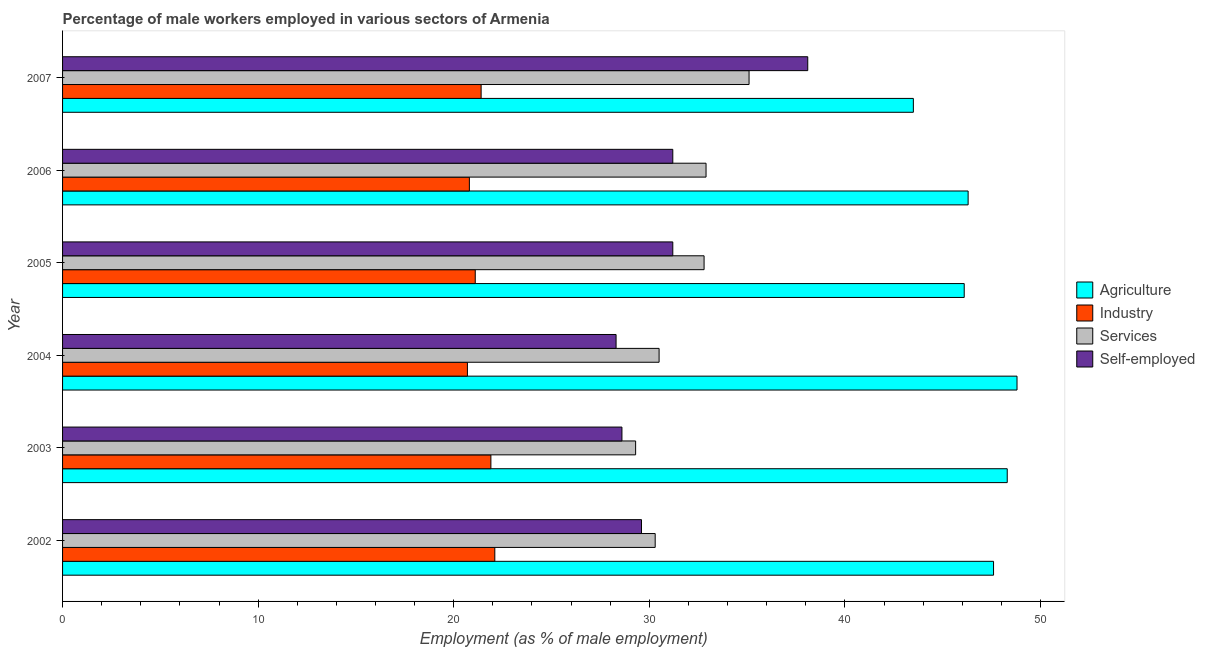How many different coloured bars are there?
Keep it short and to the point. 4. Are the number of bars on each tick of the Y-axis equal?
Your answer should be compact. Yes. How many bars are there on the 1st tick from the bottom?
Give a very brief answer. 4. What is the label of the 1st group of bars from the top?
Offer a very short reply. 2007. In how many cases, is the number of bars for a given year not equal to the number of legend labels?
Your answer should be very brief. 0. What is the percentage of male workers in industry in 2002?
Your answer should be compact. 22.1. Across all years, what is the maximum percentage of male workers in agriculture?
Offer a very short reply. 48.8. Across all years, what is the minimum percentage of male workers in agriculture?
Your response must be concise. 43.5. In which year was the percentage of male workers in industry minimum?
Keep it short and to the point. 2004. What is the total percentage of male workers in agriculture in the graph?
Your response must be concise. 280.6. What is the difference between the percentage of self employed male workers in 2006 and that in 2007?
Ensure brevity in your answer.  -6.9. What is the difference between the percentage of male workers in agriculture in 2005 and the percentage of male workers in services in 2007?
Your answer should be compact. 11. What is the average percentage of self employed male workers per year?
Make the answer very short. 31.17. What is the ratio of the percentage of male workers in services in 2005 to that in 2007?
Provide a succinct answer. 0.93. Is the percentage of male workers in agriculture in 2004 less than that in 2005?
Offer a very short reply. No. Is the difference between the percentage of male workers in industry in 2002 and 2006 greater than the difference between the percentage of male workers in services in 2002 and 2006?
Ensure brevity in your answer.  Yes. What is the difference between the highest and the lowest percentage of male workers in industry?
Make the answer very short. 1.4. Is the sum of the percentage of self employed male workers in 2002 and 2003 greater than the maximum percentage of male workers in industry across all years?
Ensure brevity in your answer.  Yes. What does the 4th bar from the top in 2005 represents?
Your answer should be compact. Agriculture. What does the 1st bar from the bottom in 2003 represents?
Your answer should be very brief. Agriculture. Is it the case that in every year, the sum of the percentage of male workers in agriculture and percentage of male workers in industry is greater than the percentage of male workers in services?
Make the answer very short. Yes. Are all the bars in the graph horizontal?
Offer a very short reply. Yes. Does the graph contain any zero values?
Keep it short and to the point. No. How many legend labels are there?
Offer a terse response. 4. What is the title of the graph?
Provide a succinct answer. Percentage of male workers employed in various sectors of Armenia. What is the label or title of the X-axis?
Provide a succinct answer. Employment (as % of male employment). What is the label or title of the Y-axis?
Your answer should be very brief. Year. What is the Employment (as % of male employment) in Agriculture in 2002?
Make the answer very short. 47.6. What is the Employment (as % of male employment) in Industry in 2002?
Your response must be concise. 22.1. What is the Employment (as % of male employment) in Services in 2002?
Ensure brevity in your answer.  30.3. What is the Employment (as % of male employment) in Self-employed in 2002?
Your answer should be compact. 29.6. What is the Employment (as % of male employment) of Agriculture in 2003?
Give a very brief answer. 48.3. What is the Employment (as % of male employment) in Industry in 2003?
Give a very brief answer. 21.9. What is the Employment (as % of male employment) in Services in 2003?
Provide a short and direct response. 29.3. What is the Employment (as % of male employment) in Self-employed in 2003?
Your answer should be compact. 28.6. What is the Employment (as % of male employment) of Agriculture in 2004?
Offer a terse response. 48.8. What is the Employment (as % of male employment) of Industry in 2004?
Offer a very short reply. 20.7. What is the Employment (as % of male employment) of Services in 2004?
Give a very brief answer. 30.5. What is the Employment (as % of male employment) of Self-employed in 2004?
Provide a short and direct response. 28.3. What is the Employment (as % of male employment) in Agriculture in 2005?
Provide a succinct answer. 46.1. What is the Employment (as % of male employment) of Industry in 2005?
Provide a short and direct response. 21.1. What is the Employment (as % of male employment) in Services in 2005?
Give a very brief answer. 32.8. What is the Employment (as % of male employment) in Self-employed in 2005?
Ensure brevity in your answer.  31.2. What is the Employment (as % of male employment) in Agriculture in 2006?
Offer a terse response. 46.3. What is the Employment (as % of male employment) of Industry in 2006?
Your response must be concise. 20.8. What is the Employment (as % of male employment) of Services in 2006?
Your answer should be very brief. 32.9. What is the Employment (as % of male employment) in Self-employed in 2006?
Your answer should be very brief. 31.2. What is the Employment (as % of male employment) in Agriculture in 2007?
Make the answer very short. 43.5. What is the Employment (as % of male employment) in Industry in 2007?
Ensure brevity in your answer.  21.4. What is the Employment (as % of male employment) in Services in 2007?
Offer a very short reply. 35.1. What is the Employment (as % of male employment) of Self-employed in 2007?
Provide a succinct answer. 38.1. Across all years, what is the maximum Employment (as % of male employment) of Agriculture?
Make the answer very short. 48.8. Across all years, what is the maximum Employment (as % of male employment) of Industry?
Your response must be concise. 22.1. Across all years, what is the maximum Employment (as % of male employment) of Services?
Make the answer very short. 35.1. Across all years, what is the maximum Employment (as % of male employment) of Self-employed?
Offer a very short reply. 38.1. Across all years, what is the minimum Employment (as % of male employment) in Agriculture?
Keep it short and to the point. 43.5. Across all years, what is the minimum Employment (as % of male employment) in Industry?
Provide a short and direct response. 20.7. Across all years, what is the minimum Employment (as % of male employment) of Services?
Your answer should be very brief. 29.3. Across all years, what is the minimum Employment (as % of male employment) in Self-employed?
Your answer should be compact. 28.3. What is the total Employment (as % of male employment) of Agriculture in the graph?
Your answer should be compact. 280.6. What is the total Employment (as % of male employment) of Industry in the graph?
Keep it short and to the point. 128. What is the total Employment (as % of male employment) of Services in the graph?
Offer a terse response. 190.9. What is the total Employment (as % of male employment) in Self-employed in the graph?
Your answer should be very brief. 187. What is the difference between the Employment (as % of male employment) of Industry in 2002 and that in 2003?
Give a very brief answer. 0.2. What is the difference between the Employment (as % of male employment) of Industry in 2002 and that in 2004?
Your answer should be compact. 1.4. What is the difference between the Employment (as % of male employment) of Services in 2002 and that in 2004?
Your answer should be very brief. -0.2. What is the difference between the Employment (as % of male employment) of Self-employed in 2002 and that in 2004?
Provide a short and direct response. 1.3. What is the difference between the Employment (as % of male employment) in Agriculture in 2002 and that in 2005?
Ensure brevity in your answer.  1.5. What is the difference between the Employment (as % of male employment) of Industry in 2002 and that in 2005?
Ensure brevity in your answer.  1. What is the difference between the Employment (as % of male employment) in Services in 2002 and that in 2005?
Ensure brevity in your answer.  -2.5. What is the difference between the Employment (as % of male employment) in Services in 2002 and that in 2006?
Offer a terse response. -2.6. What is the difference between the Employment (as % of male employment) of Self-employed in 2002 and that in 2006?
Make the answer very short. -1.6. What is the difference between the Employment (as % of male employment) in Agriculture in 2002 and that in 2007?
Provide a succinct answer. 4.1. What is the difference between the Employment (as % of male employment) in Industry in 2002 and that in 2007?
Your answer should be compact. 0.7. What is the difference between the Employment (as % of male employment) of Agriculture in 2003 and that in 2004?
Offer a very short reply. -0.5. What is the difference between the Employment (as % of male employment) of Industry in 2003 and that in 2004?
Provide a short and direct response. 1.2. What is the difference between the Employment (as % of male employment) in Agriculture in 2003 and that in 2005?
Your answer should be very brief. 2.2. What is the difference between the Employment (as % of male employment) in Services in 2003 and that in 2005?
Your answer should be very brief. -3.5. What is the difference between the Employment (as % of male employment) of Self-employed in 2003 and that in 2005?
Ensure brevity in your answer.  -2.6. What is the difference between the Employment (as % of male employment) of Agriculture in 2003 and that in 2006?
Provide a succinct answer. 2. What is the difference between the Employment (as % of male employment) in Services in 2003 and that in 2006?
Your answer should be very brief. -3.6. What is the difference between the Employment (as % of male employment) in Agriculture in 2003 and that in 2007?
Your answer should be compact. 4.8. What is the difference between the Employment (as % of male employment) in Industry in 2003 and that in 2007?
Your answer should be very brief. 0.5. What is the difference between the Employment (as % of male employment) in Services in 2003 and that in 2007?
Make the answer very short. -5.8. What is the difference between the Employment (as % of male employment) of Self-employed in 2003 and that in 2007?
Make the answer very short. -9.5. What is the difference between the Employment (as % of male employment) of Agriculture in 2004 and that in 2006?
Keep it short and to the point. 2.5. What is the difference between the Employment (as % of male employment) in Industry in 2004 and that in 2006?
Your response must be concise. -0.1. What is the difference between the Employment (as % of male employment) of Services in 2004 and that in 2006?
Offer a very short reply. -2.4. What is the difference between the Employment (as % of male employment) of Agriculture in 2004 and that in 2007?
Make the answer very short. 5.3. What is the difference between the Employment (as % of male employment) of Self-employed in 2004 and that in 2007?
Offer a terse response. -9.8. What is the difference between the Employment (as % of male employment) in Self-employed in 2005 and that in 2006?
Your answer should be compact. 0. What is the difference between the Employment (as % of male employment) of Industry in 2005 and that in 2007?
Make the answer very short. -0.3. What is the difference between the Employment (as % of male employment) of Agriculture in 2006 and that in 2007?
Provide a succinct answer. 2.8. What is the difference between the Employment (as % of male employment) of Industry in 2006 and that in 2007?
Give a very brief answer. -0.6. What is the difference between the Employment (as % of male employment) of Services in 2006 and that in 2007?
Give a very brief answer. -2.2. What is the difference between the Employment (as % of male employment) in Agriculture in 2002 and the Employment (as % of male employment) in Industry in 2003?
Keep it short and to the point. 25.7. What is the difference between the Employment (as % of male employment) of Services in 2002 and the Employment (as % of male employment) of Self-employed in 2003?
Offer a terse response. 1.7. What is the difference between the Employment (as % of male employment) of Agriculture in 2002 and the Employment (as % of male employment) of Industry in 2004?
Offer a very short reply. 26.9. What is the difference between the Employment (as % of male employment) of Agriculture in 2002 and the Employment (as % of male employment) of Self-employed in 2004?
Give a very brief answer. 19.3. What is the difference between the Employment (as % of male employment) of Industry in 2002 and the Employment (as % of male employment) of Self-employed in 2004?
Ensure brevity in your answer.  -6.2. What is the difference between the Employment (as % of male employment) of Industry in 2002 and the Employment (as % of male employment) of Services in 2005?
Keep it short and to the point. -10.7. What is the difference between the Employment (as % of male employment) in Services in 2002 and the Employment (as % of male employment) in Self-employed in 2005?
Provide a short and direct response. -0.9. What is the difference between the Employment (as % of male employment) of Agriculture in 2002 and the Employment (as % of male employment) of Industry in 2006?
Offer a terse response. 26.8. What is the difference between the Employment (as % of male employment) in Agriculture in 2002 and the Employment (as % of male employment) in Self-employed in 2006?
Your answer should be very brief. 16.4. What is the difference between the Employment (as % of male employment) of Industry in 2002 and the Employment (as % of male employment) of Services in 2006?
Provide a succinct answer. -10.8. What is the difference between the Employment (as % of male employment) of Industry in 2002 and the Employment (as % of male employment) of Self-employed in 2006?
Keep it short and to the point. -9.1. What is the difference between the Employment (as % of male employment) in Agriculture in 2002 and the Employment (as % of male employment) in Industry in 2007?
Your answer should be compact. 26.2. What is the difference between the Employment (as % of male employment) of Agriculture in 2002 and the Employment (as % of male employment) of Self-employed in 2007?
Ensure brevity in your answer.  9.5. What is the difference between the Employment (as % of male employment) in Industry in 2002 and the Employment (as % of male employment) in Self-employed in 2007?
Give a very brief answer. -16. What is the difference between the Employment (as % of male employment) in Agriculture in 2003 and the Employment (as % of male employment) in Industry in 2004?
Give a very brief answer. 27.6. What is the difference between the Employment (as % of male employment) of Agriculture in 2003 and the Employment (as % of male employment) of Services in 2004?
Your answer should be compact. 17.8. What is the difference between the Employment (as % of male employment) of Industry in 2003 and the Employment (as % of male employment) of Services in 2004?
Keep it short and to the point. -8.6. What is the difference between the Employment (as % of male employment) of Services in 2003 and the Employment (as % of male employment) of Self-employed in 2004?
Your response must be concise. 1. What is the difference between the Employment (as % of male employment) of Agriculture in 2003 and the Employment (as % of male employment) of Industry in 2005?
Your response must be concise. 27.2. What is the difference between the Employment (as % of male employment) in Agriculture in 2003 and the Employment (as % of male employment) in Self-employed in 2005?
Your answer should be very brief. 17.1. What is the difference between the Employment (as % of male employment) in Industry in 2003 and the Employment (as % of male employment) in Services in 2005?
Ensure brevity in your answer.  -10.9. What is the difference between the Employment (as % of male employment) in Agriculture in 2003 and the Employment (as % of male employment) in Services in 2006?
Ensure brevity in your answer.  15.4. What is the difference between the Employment (as % of male employment) in Industry in 2003 and the Employment (as % of male employment) in Self-employed in 2006?
Make the answer very short. -9.3. What is the difference between the Employment (as % of male employment) of Services in 2003 and the Employment (as % of male employment) of Self-employed in 2006?
Offer a very short reply. -1.9. What is the difference between the Employment (as % of male employment) of Agriculture in 2003 and the Employment (as % of male employment) of Industry in 2007?
Your response must be concise. 26.9. What is the difference between the Employment (as % of male employment) of Agriculture in 2003 and the Employment (as % of male employment) of Services in 2007?
Provide a short and direct response. 13.2. What is the difference between the Employment (as % of male employment) in Agriculture in 2003 and the Employment (as % of male employment) in Self-employed in 2007?
Provide a short and direct response. 10.2. What is the difference between the Employment (as % of male employment) of Industry in 2003 and the Employment (as % of male employment) of Self-employed in 2007?
Make the answer very short. -16.2. What is the difference between the Employment (as % of male employment) in Services in 2003 and the Employment (as % of male employment) in Self-employed in 2007?
Your response must be concise. -8.8. What is the difference between the Employment (as % of male employment) of Agriculture in 2004 and the Employment (as % of male employment) of Industry in 2005?
Ensure brevity in your answer.  27.7. What is the difference between the Employment (as % of male employment) of Agriculture in 2004 and the Employment (as % of male employment) of Services in 2005?
Offer a terse response. 16. What is the difference between the Employment (as % of male employment) in Agriculture in 2004 and the Employment (as % of male employment) in Self-employed in 2005?
Your answer should be compact. 17.6. What is the difference between the Employment (as % of male employment) in Industry in 2004 and the Employment (as % of male employment) in Services in 2005?
Keep it short and to the point. -12.1. What is the difference between the Employment (as % of male employment) of Industry in 2004 and the Employment (as % of male employment) of Self-employed in 2006?
Your answer should be very brief. -10.5. What is the difference between the Employment (as % of male employment) in Agriculture in 2004 and the Employment (as % of male employment) in Industry in 2007?
Keep it short and to the point. 27.4. What is the difference between the Employment (as % of male employment) of Industry in 2004 and the Employment (as % of male employment) of Services in 2007?
Keep it short and to the point. -14.4. What is the difference between the Employment (as % of male employment) of Industry in 2004 and the Employment (as % of male employment) of Self-employed in 2007?
Provide a short and direct response. -17.4. What is the difference between the Employment (as % of male employment) of Agriculture in 2005 and the Employment (as % of male employment) of Industry in 2006?
Offer a very short reply. 25.3. What is the difference between the Employment (as % of male employment) of Agriculture in 2005 and the Employment (as % of male employment) of Self-employed in 2006?
Provide a succinct answer. 14.9. What is the difference between the Employment (as % of male employment) of Industry in 2005 and the Employment (as % of male employment) of Services in 2006?
Your response must be concise. -11.8. What is the difference between the Employment (as % of male employment) in Industry in 2005 and the Employment (as % of male employment) in Self-employed in 2006?
Provide a short and direct response. -10.1. What is the difference between the Employment (as % of male employment) of Agriculture in 2005 and the Employment (as % of male employment) of Industry in 2007?
Offer a terse response. 24.7. What is the difference between the Employment (as % of male employment) of Agriculture in 2005 and the Employment (as % of male employment) of Self-employed in 2007?
Give a very brief answer. 8. What is the difference between the Employment (as % of male employment) of Services in 2005 and the Employment (as % of male employment) of Self-employed in 2007?
Your response must be concise. -5.3. What is the difference between the Employment (as % of male employment) of Agriculture in 2006 and the Employment (as % of male employment) of Industry in 2007?
Ensure brevity in your answer.  24.9. What is the difference between the Employment (as % of male employment) in Agriculture in 2006 and the Employment (as % of male employment) in Self-employed in 2007?
Make the answer very short. 8.2. What is the difference between the Employment (as % of male employment) of Industry in 2006 and the Employment (as % of male employment) of Services in 2007?
Make the answer very short. -14.3. What is the difference between the Employment (as % of male employment) of Industry in 2006 and the Employment (as % of male employment) of Self-employed in 2007?
Your response must be concise. -17.3. What is the average Employment (as % of male employment) of Agriculture per year?
Your answer should be compact. 46.77. What is the average Employment (as % of male employment) of Industry per year?
Offer a very short reply. 21.33. What is the average Employment (as % of male employment) of Services per year?
Ensure brevity in your answer.  31.82. What is the average Employment (as % of male employment) in Self-employed per year?
Your response must be concise. 31.17. In the year 2002, what is the difference between the Employment (as % of male employment) in Agriculture and Employment (as % of male employment) in Industry?
Provide a short and direct response. 25.5. In the year 2002, what is the difference between the Employment (as % of male employment) in Industry and Employment (as % of male employment) in Services?
Provide a short and direct response. -8.2. In the year 2002, what is the difference between the Employment (as % of male employment) in Industry and Employment (as % of male employment) in Self-employed?
Offer a very short reply. -7.5. In the year 2003, what is the difference between the Employment (as % of male employment) of Agriculture and Employment (as % of male employment) of Industry?
Provide a short and direct response. 26.4. In the year 2003, what is the difference between the Employment (as % of male employment) of Industry and Employment (as % of male employment) of Services?
Give a very brief answer. -7.4. In the year 2003, what is the difference between the Employment (as % of male employment) of Industry and Employment (as % of male employment) of Self-employed?
Ensure brevity in your answer.  -6.7. In the year 2003, what is the difference between the Employment (as % of male employment) of Services and Employment (as % of male employment) of Self-employed?
Provide a short and direct response. 0.7. In the year 2004, what is the difference between the Employment (as % of male employment) of Agriculture and Employment (as % of male employment) of Industry?
Provide a short and direct response. 28.1. In the year 2004, what is the difference between the Employment (as % of male employment) in Industry and Employment (as % of male employment) in Services?
Your response must be concise. -9.8. In the year 2004, what is the difference between the Employment (as % of male employment) in Industry and Employment (as % of male employment) in Self-employed?
Give a very brief answer. -7.6. In the year 2005, what is the difference between the Employment (as % of male employment) of Agriculture and Employment (as % of male employment) of Services?
Provide a short and direct response. 13.3. In the year 2005, what is the difference between the Employment (as % of male employment) of Services and Employment (as % of male employment) of Self-employed?
Give a very brief answer. 1.6. In the year 2006, what is the difference between the Employment (as % of male employment) of Agriculture and Employment (as % of male employment) of Industry?
Give a very brief answer. 25.5. In the year 2006, what is the difference between the Employment (as % of male employment) in Industry and Employment (as % of male employment) in Services?
Your answer should be compact. -12.1. In the year 2006, what is the difference between the Employment (as % of male employment) in Services and Employment (as % of male employment) in Self-employed?
Ensure brevity in your answer.  1.7. In the year 2007, what is the difference between the Employment (as % of male employment) of Agriculture and Employment (as % of male employment) of Industry?
Provide a short and direct response. 22.1. In the year 2007, what is the difference between the Employment (as % of male employment) of Agriculture and Employment (as % of male employment) of Self-employed?
Make the answer very short. 5.4. In the year 2007, what is the difference between the Employment (as % of male employment) of Industry and Employment (as % of male employment) of Services?
Give a very brief answer. -13.7. In the year 2007, what is the difference between the Employment (as % of male employment) in Industry and Employment (as % of male employment) in Self-employed?
Give a very brief answer. -16.7. In the year 2007, what is the difference between the Employment (as % of male employment) of Services and Employment (as % of male employment) of Self-employed?
Your answer should be compact. -3. What is the ratio of the Employment (as % of male employment) in Agriculture in 2002 to that in 2003?
Your answer should be very brief. 0.99. What is the ratio of the Employment (as % of male employment) in Industry in 2002 to that in 2003?
Ensure brevity in your answer.  1.01. What is the ratio of the Employment (as % of male employment) of Services in 2002 to that in 2003?
Your answer should be compact. 1.03. What is the ratio of the Employment (as % of male employment) of Self-employed in 2002 to that in 2003?
Keep it short and to the point. 1.03. What is the ratio of the Employment (as % of male employment) of Agriculture in 2002 to that in 2004?
Keep it short and to the point. 0.98. What is the ratio of the Employment (as % of male employment) in Industry in 2002 to that in 2004?
Your answer should be compact. 1.07. What is the ratio of the Employment (as % of male employment) of Self-employed in 2002 to that in 2004?
Your response must be concise. 1.05. What is the ratio of the Employment (as % of male employment) of Agriculture in 2002 to that in 2005?
Provide a short and direct response. 1.03. What is the ratio of the Employment (as % of male employment) in Industry in 2002 to that in 2005?
Make the answer very short. 1.05. What is the ratio of the Employment (as % of male employment) of Services in 2002 to that in 2005?
Provide a succinct answer. 0.92. What is the ratio of the Employment (as % of male employment) in Self-employed in 2002 to that in 2005?
Your answer should be compact. 0.95. What is the ratio of the Employment (as % of male employment) in Agriculture in 2002 to that in 2006?
Ensure brevity in your answer.  1.03. What is the ratio of the Employment (as % of male employment) of Services in 2002 to that in 2006?
Offer a terse response. 0.92. What is the ratio of the Employment (as % of male employment) in Self-employed in 2002 to that in 2006?
Provide a succinct answer. 0.95. What is the ratio of the Employment (as % of male employment) in Agriculture in 2002 to that in 2007?
Ensure brevity in your answer.  1.09. What is the ratio of the Employment (as % of male employment) in Industry in 2002 to that in 2007?
Your answer should be compact. 1.03. What is the ratio of the Employment (as % of male employment) of Services in 2002 to that in 2007?
Provide a succinct answer. 0.86. What is the ratio of the Employment (as % of male employment) of Self-employed in 2002 to that in 2007?
Offer a terse response. 0.78. What is the ratio of the Employment (as % of male employment) in Agriculture in 2003 to that in 2004?
Provide a succinct answer. 0.99. What is the ratio of the Employment (as % of male employment) in Industry in 2003 to that in 2004?
Keep it short and to the point. 1.06. What is the ratio of the Employment (as % of male employment) in Services in 2003 to that in 2004?
Your response must be concise. 0.96. What is the ratio of the Employment (as % of male employment) in Self-employed in 2003 to that in 2004?
Provide a short and direct response. 1.01. What is the ratio of the Employment (as % of male employment) of Agriculture in 2003 to that in 2005?
Your response must be concise. 1.05. What is the ratio of the Employment (as % of male employment) in Industry in 2003 to that in 2005?
Provide a short and direct response. 1.04. What is the ratio of the Employment (as % of male employment) in Services in 2003 to that in 2005?
Make the answer very short. 0.89. What is the ratio of the Employment (as % of male employment) in Self-employed in 2003 to that in 2005?
Your response must be concise. 0.92. What is the ratio of the Employment (as % of male employment) in Agriculture in 2003 to that in 2006?
Your answer should be compact. 1.04. What is the ratio of the Employment (as % of male employment) of Industry in 2003 to that in 2006?
Your answer should be compact. 1.05. What is the ratio of the Employment (as % of male employment) in Services in 2003 to that in 2006?
Make the answer very short. 0.89. What is the ratio of the Employment (as % of male employment) of Self-employed in 2003 to that in 2006?
Your answer should be very brief. 0.92. What is the ratio of the Employment (as % of male employment) in Agriculture in 2003 to that in 2007?
Ensure brevity in your answer.  1.11. What is the ratio of the Employment (as % of male employment) in Industry in 2003 to that in 2007?
Keep it short and to the point. 1.02. What is the ratio of the Employment (as % of male employment) in Services in 2003 to that in 2007?
Ensure brevity in your answer.  0.83. What is the ratio of the Employment (as % of male employment) of Self-employed in 2003 to that in 2007?
Ensure brevity in your answer.  0.75. What is the ratio of the Employment (as % of male employment) of Agriculture in 2004 to that in 2005?
Give a very brief answer. 1.06. What is the ratio of the Employment (as % of male employment) in Services in 2004 to that in 2005?
Your answer should be very brief. 0.93. What is the ratio of the Employment (as % of male employment) in Self-employed in 2004 to that in 2005?
Your answer should be compact. 0.91. What is the ratio of the Employment (as % of male employment) of Agriculture in 2004 to that in 2006?
Your answer should be compact. 1.05. What is the ratio of the Employment (as % of male employment) in Industry in 2004 to that in 2006?
Provide a short and direct response. 1. What is the ratio of the Employment (as % of male employment) of Services in 2004 to that in 2006?
Give a very brief answer. 0.93. What is the ratio of the Employment (as % of male employment) of Self-employed in 2004 to that in 2006?
Your response must be concise. 0.91. What is the ratio of the Employment (as % of male employment) in Agriculture in 2004 to that in 2007?
Keep it short and to the point. 1.12. What is the ratio of the Employment (as % of male employment) of Industry in 2004 to that in 2007?
Give a very brief answer. 0.97. What is the ratio of the Employment (as % of male employment) of Services in 2004 to that in 2007?
Provide a short and direct response. 0.87. What is the ratio of the Employment (as % of male employment) of Self-employed in 2004 to that in 2007?
Your answer should be compact. 0.74. What is the ratio of the Employment (as % of male employment) of Industry in 2005 to that in 2006?
Make the answer very short. 1.01. What is the ratio of the Employment (as % of male employment) of Services in 2005 to that in 2006?
Your answer should be compact. 1. What is the ratio of the Employment (as % of male employment) in Self-employed in 2005 to that in 2006?
Give a very brief answer. 1. What is the ratio of the Employment (as % of male employment) in Agriculture in 2005 to that in 2007?
Ensure brevity in your answer.  1.06. What is the ratio of the Employment (as % of male employment) of Industry in 2005 to that in 2007?
Ensure brevity in your answer.  0.99. What is the ratio of the Employment (as % of male employment) in Services in 2005 to that in 2007?
Provide a succinct answer. 0.93. What is the ratio of the Employment (as % of male employment) in Self-employed in 2005 to that in 2007?
Offer a terse response. 0.82. What is the ratio of the Employment (as % of male employment) of Agriculture in 2006 to that in 2007?
Ensure brevity in your answer.  1.06. What is the ratio of the Employment (as % of male employment) in Industry in 2006 to that in 2007?
Provide a short and direct response. 0.97. What is the ratio of the Employment (as % of male employment) in Services in 2006 to that in 2007?
Give a very brief answer. 0.94. What is the ratio of the Employment (as % of male employment) of Self-employed in 2006 to that in 2007?
Provide a succinct answer. 0.82. What is the difference between the highest and the second highest Employment (as % of male employment) of Self-employed?
Offer a very short reply. 6.9. What is the difference between the highest and the lowest Employment (as % of male employment) of Industry?
Offer a very short reply. 1.4. 